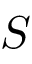<formula> <loc_0><loc_0><loc_500><loc_500>S</formula> 